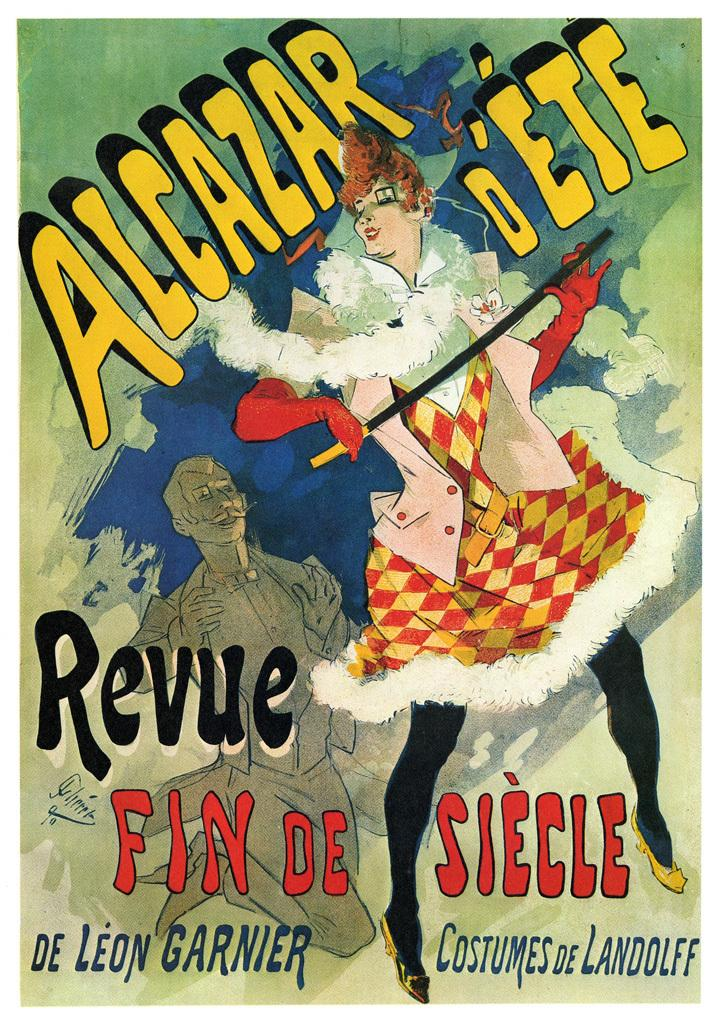Provide a one-sentence caption for the provided image. An old animated advertisement for Alcarzar D'Ete shows a woman in a checkered dress holding a sword while a man claps. 